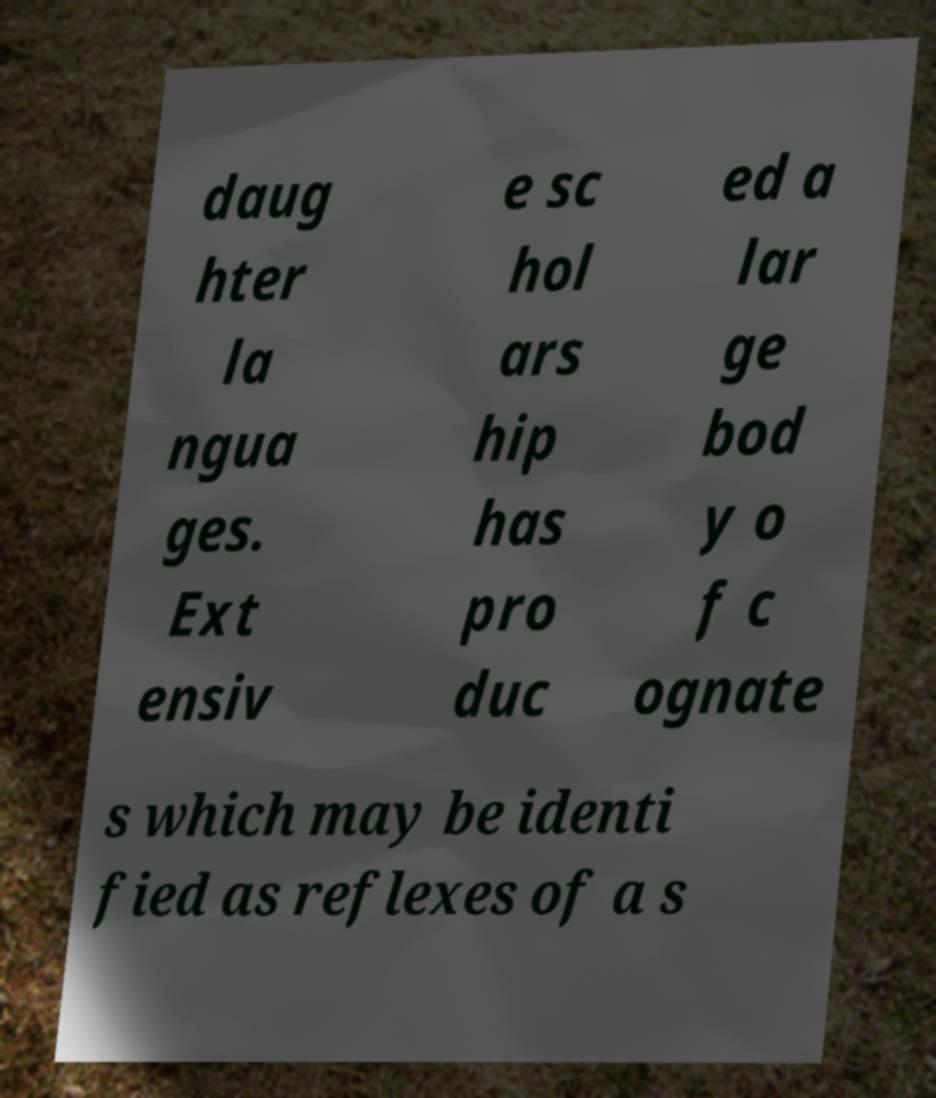Can you accurately transcribe the text from the provided image for me? daug hter la ngua ges. Ext ensiv e sc hol ars hip has pro duc ed a lar ge bod y o f c ognate s which may be identi fied as reflexes of a s 